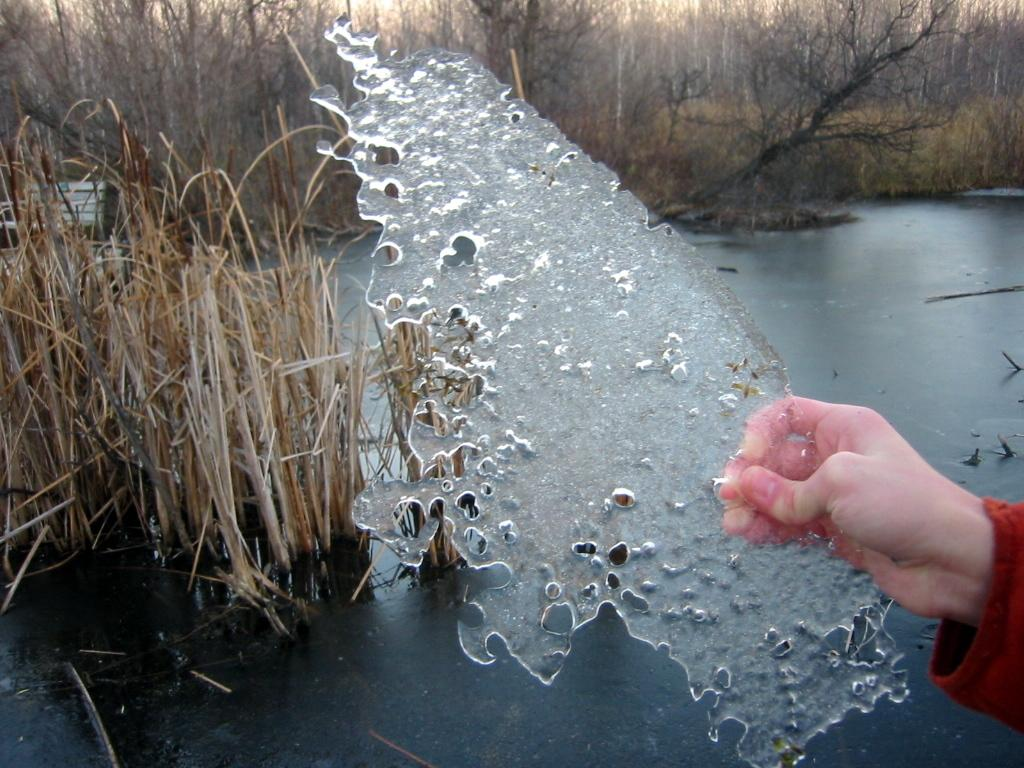What is the person's hand holding in the image? There is an object being held by a person's hand in the image. What can be seen in the background of the image? There is water visible in the image, as well as trees. What type of vegetation is present in the image? Dry plants are present in the image. What type of car is visible in the image? There is no car present in the image. What type of tin can be seen in the image? There is no tin present in the image. 